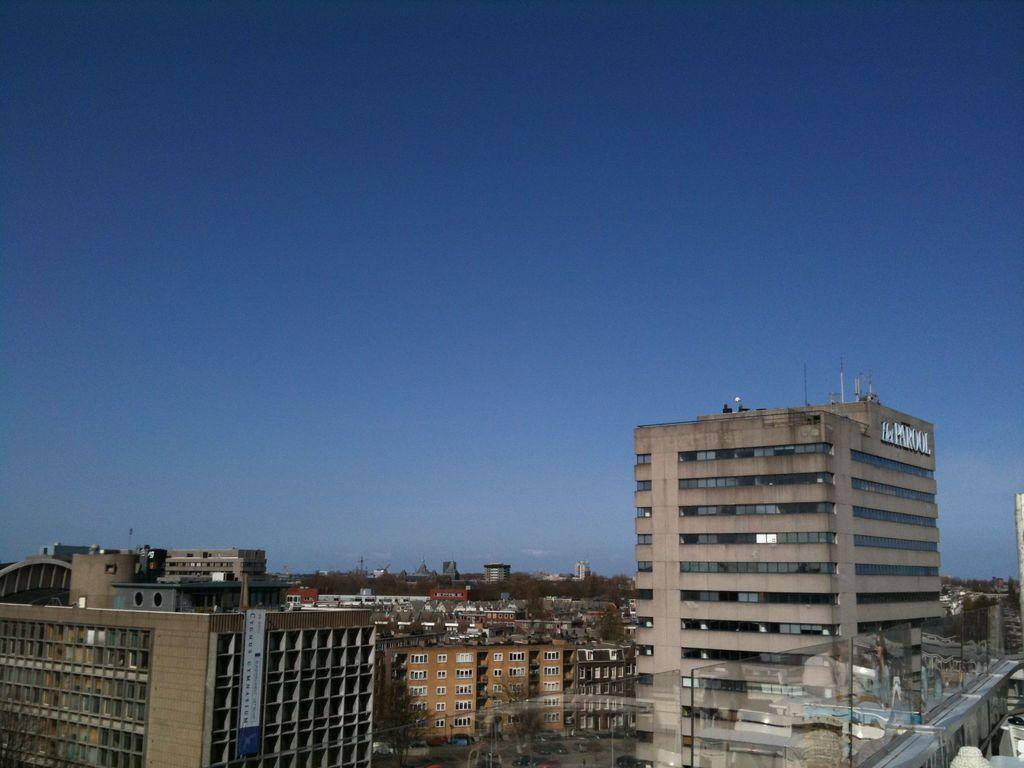Can you describe this image briefly? In this image we can see many buildings. We can also see some trees at the bottom. Sky is also visible. 